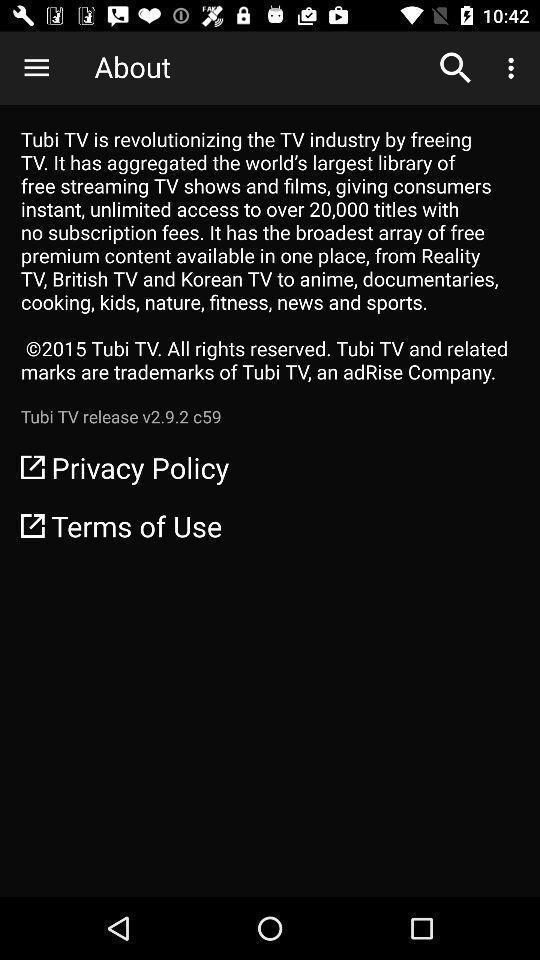Provide a textual representation of this image. Screen displaying about the terms and privacy of the app. 